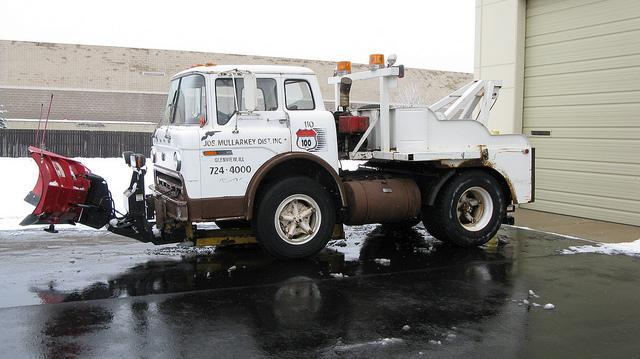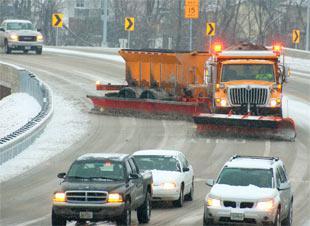The first image is the image on the left, the second image is the image on the right. For the images shown, is this caption "There are more than three vehicles in the right image." true? Answer yes or no. Yes. The first image is the image on the left, the second image is the image on the right. Considering the images on both sides, is "Both images feature in the foreground a tow plow pulled by a truck with a bright yellow cab." valid? Answer yes or no. No. 